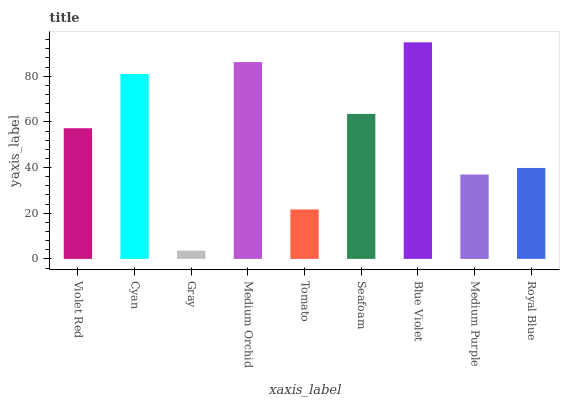Is Gray the minimum?
Answer yes or no. Yes. Is Blue Violet the maximum?
Answer yes or no. Yes. Is Cyan the minimum?
Answer yes or no. No. Is Cyan the maximum?
Answer yes or no. No. Is Cyan greater than Violet Red?
Answer yes or no. Yes. Is Violet Red less than Cyan?
Answer yes or no. Yes. Is Violet Red greater than Cyan?
Answer yes or no. No. Is Cyan less than Violet Red?
Answer yes or no. No. Is Violet Red the high median?
Answer yes or no. Yes. Is Violet Red the low median?
Answer yes or no. Yes. Is Seafoam the high median?
Answer yes or no. No. Is Gray the low median?
Answer yes or no. No. 